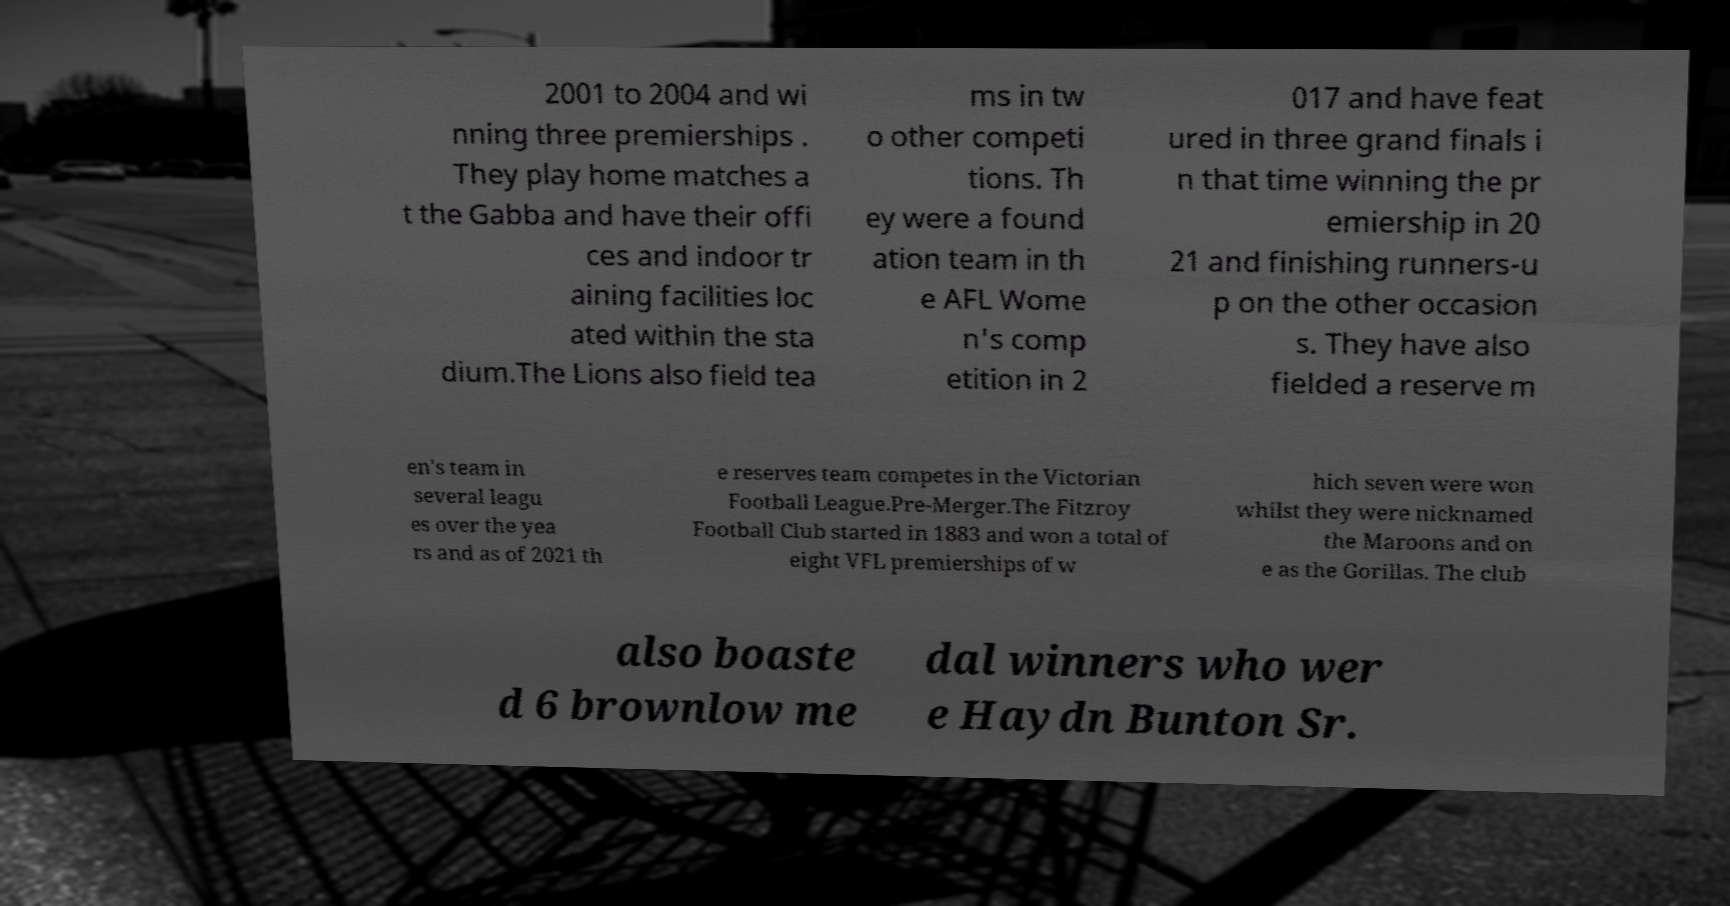Please identify and transcribe the text found in this image. 2001 to 2004 and wi nning three premierships . They play home matches a t the Gabba and have their offi ces and indoor tr aining facilities loc ated within the sta dium.The Lions also field tea ms in tw o other competi tions. Th ey were a found ation team in th e AFL Wome n's comp etition in 2 017 and have feat ured in three grand finals i n that time winning the pr emiership in 20 21 and finishing runners-u p on the other occasion s. They have also fielded a reserve m en's team in several leagu es over the yea rs and as of 2021 th e reserves team competes in the Victorian Football League.Pre-Merger.The Fitzroy Football Club started in 1883 and won a total of eight VFL premierships of w hich seven were won whilst they were nicknamed the Maroons and on e as the Gorillas. The club also boaste d 6 brownlow me dal winners who wer e Haydn Bunton Sr. 